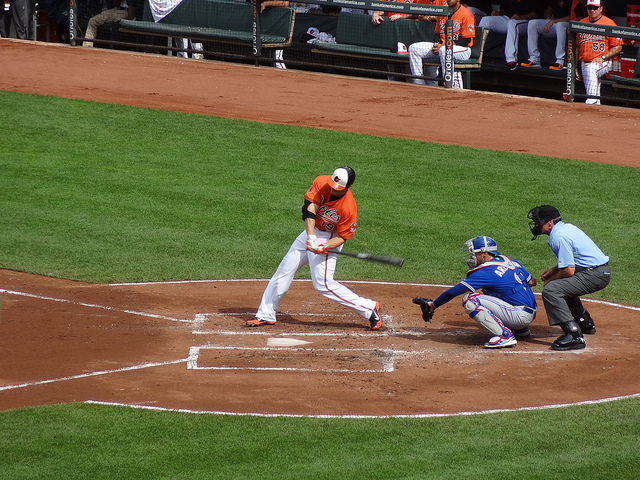How many people are there? In the image, there are three people visible involved in the baseball game: the batter, the catcher, and the umpire. 